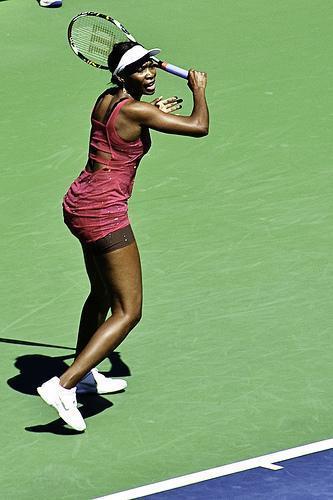How many tennis players are there?
Give a very brief answer. 1. 